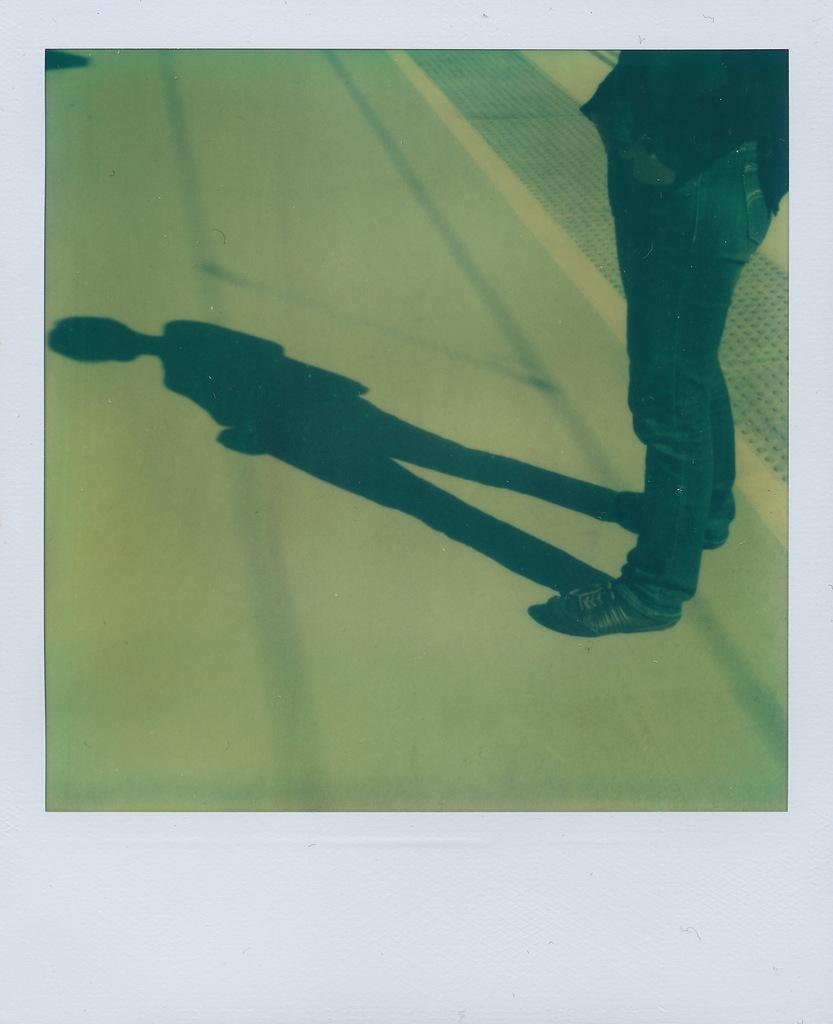What is the main subject of the image? There is a photograph in the image. What is shown in the photograph? The photograph depicts a person. Where is the person located in the photograph? The person is standing on the road. What type of jar is visible in the image? There is no jar present in the image. How many passengers are in the image? The image only shows a photograph of a person standing on the road, so there are no passengers present. 